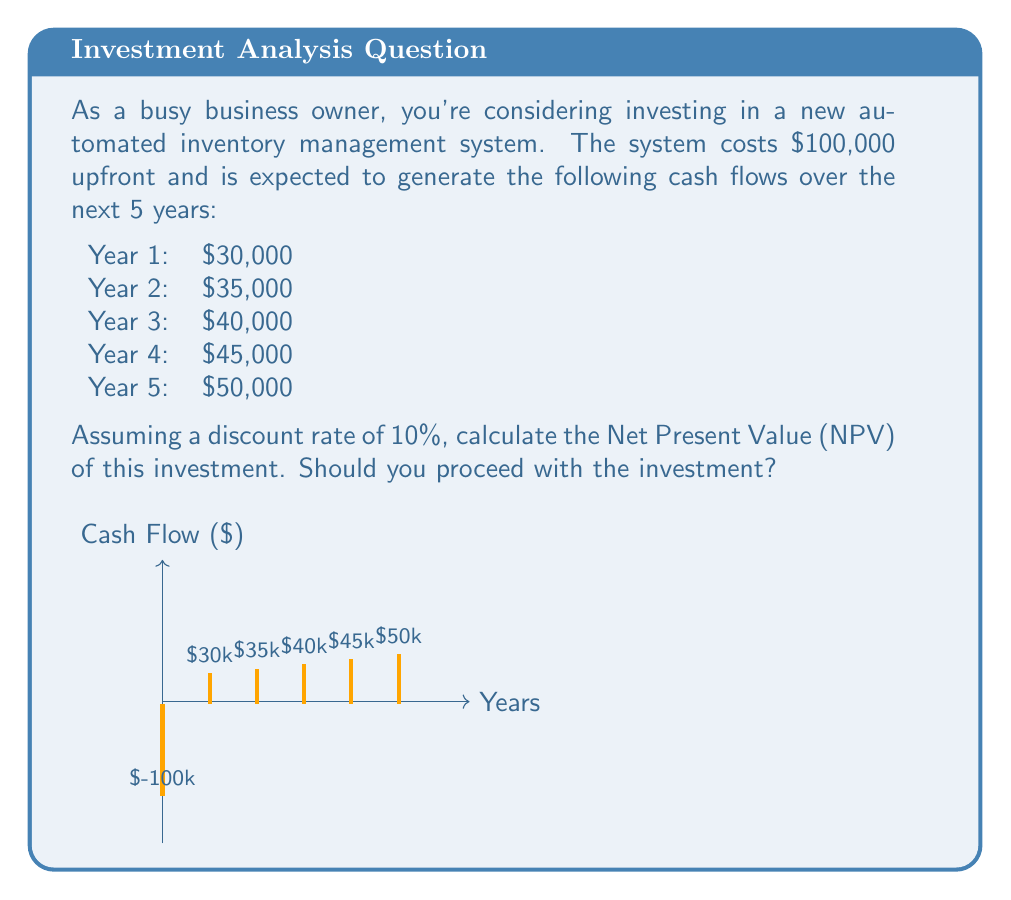Can you answer this question? To calculate the NPV, we need to follow these steps:

1. Calculate the present value of each future cash flow:
   PV = CF / (1 + r)^t, where CF is cash flow, r is discount rate, and t is time period.

2. Sum all present values, including the initial investment.

Let's calculate:

Initial Investment: -$100,000

Year 1: $30,000 / (1 + 0.10)^1 = $27,272.73
Year 2: $35,000 / (1 + 0.10)^2 = $28,925.62
Year 3: $40,000 / (1 + 0.10)^3 = $30,052.41
Year 4: $45,000 / (1 + 0.10)^4 = $30,746.98
Year 5: $50,000 / (1 + 0.10)^5 = $31,046.07

Now, let's sum all these values:

$$NPV = -100,000 + 27,272.73 + 28,925.62 + 30,052.41 + 30,746.98 + 31,046.07$$
$$NPV = $48,043.81$$

Since the NPV is positive, you should proceed with the investment as it adds value to your business.
Answer: $48,043.81; Invest 